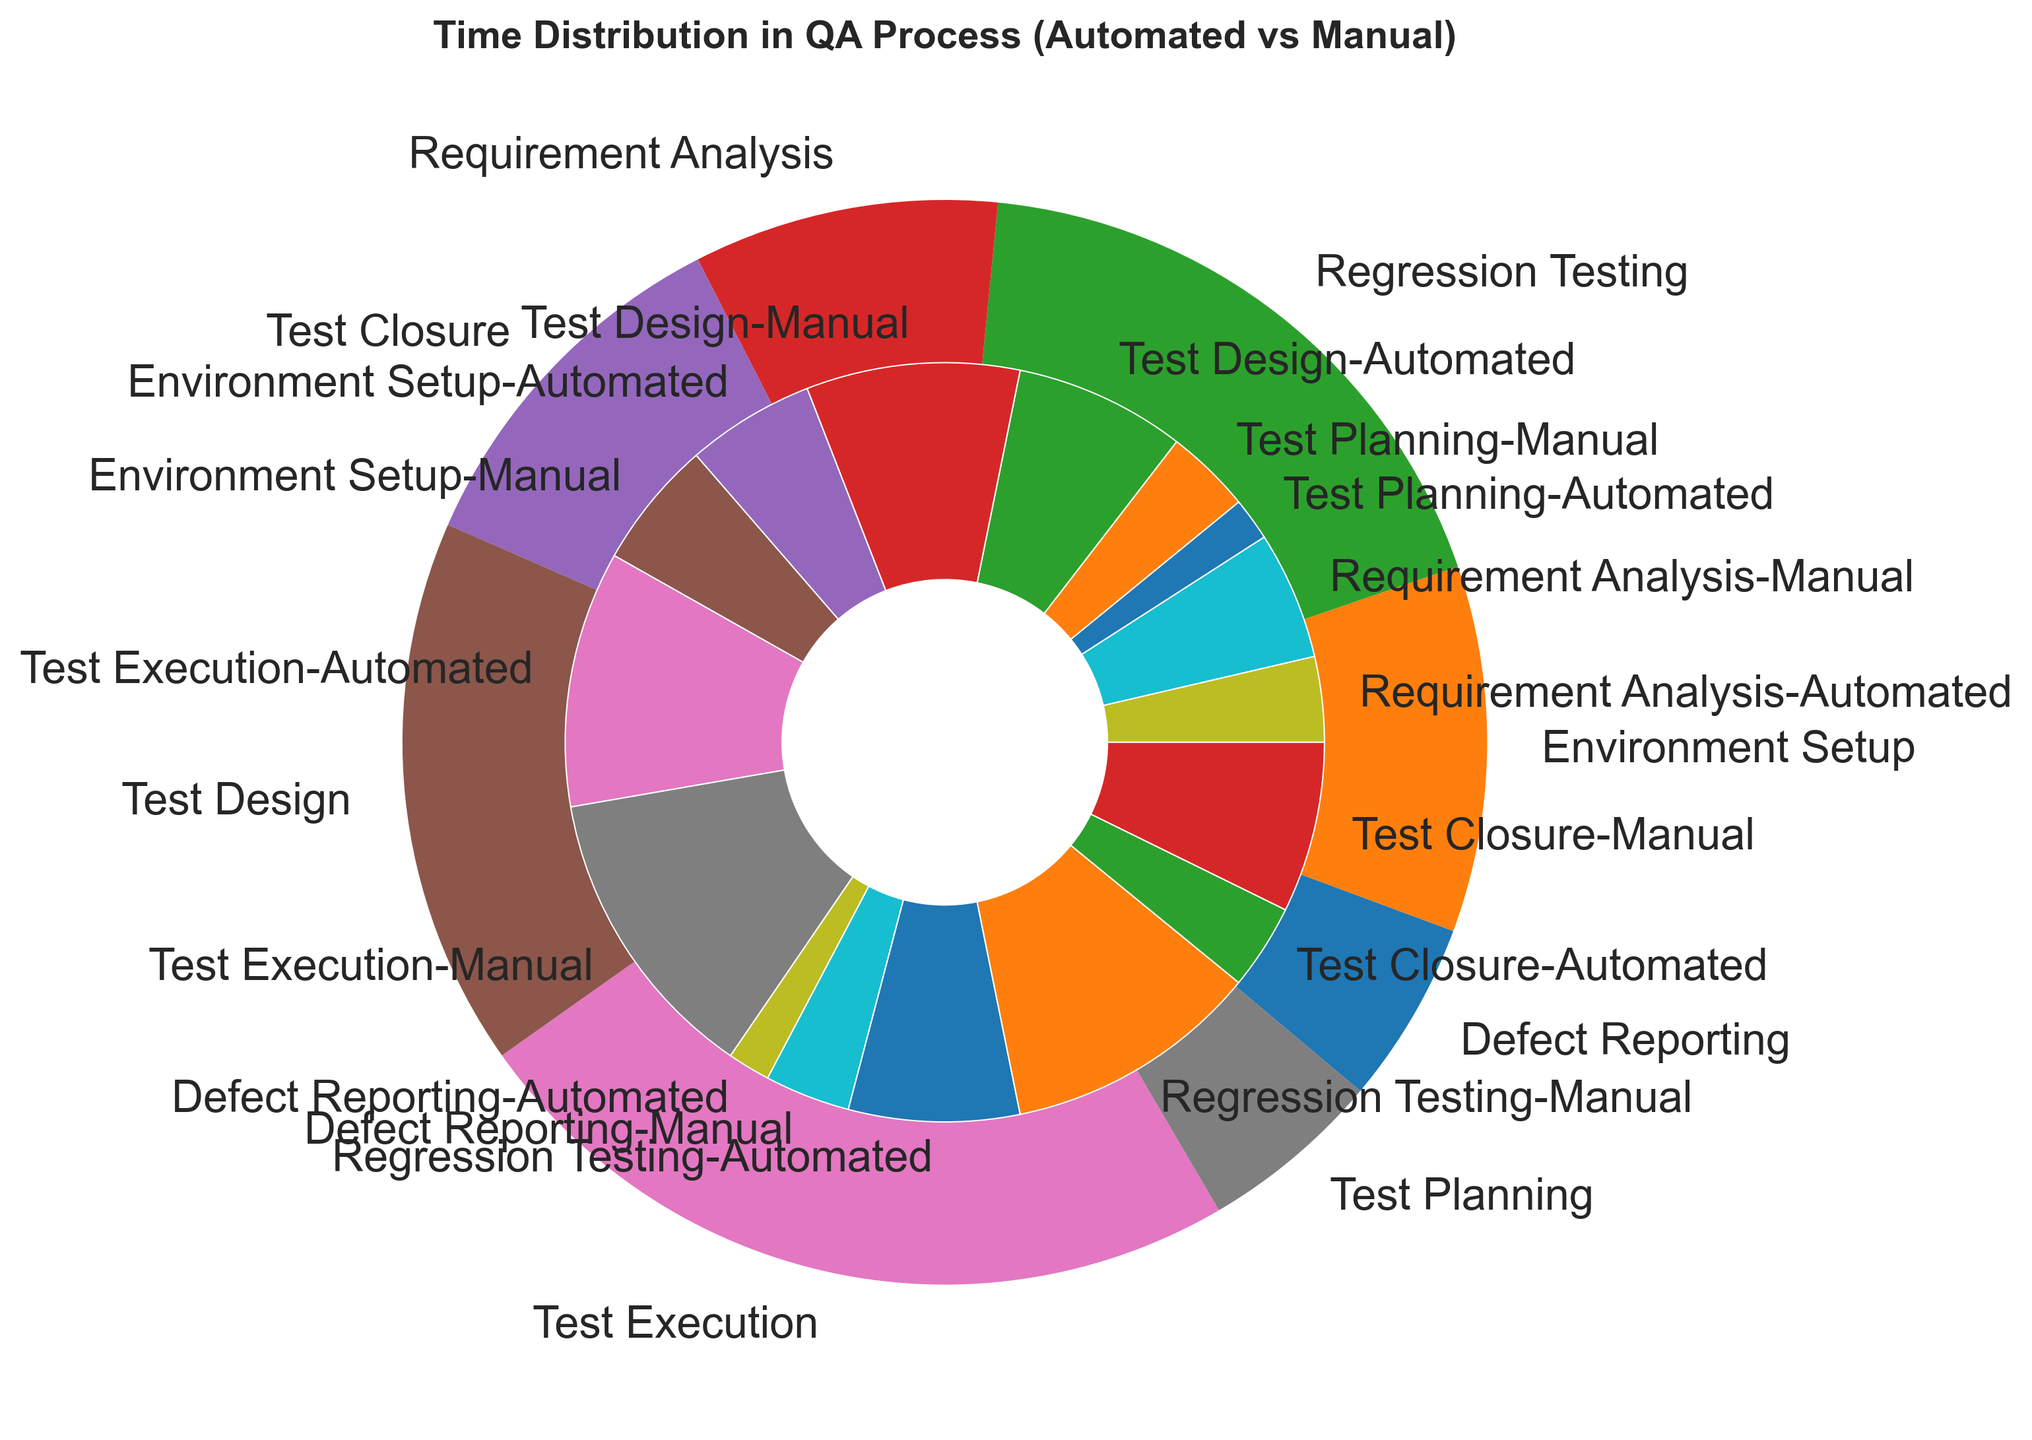What is the total time spent on Requirement Analysis? Add the time spent on both Automated (2 hours) and Manual (3 hours) stages for Requirement Analysis. 2 + 3 = 5
Answer: 5 hours Which stage takes the longest total time in the QA process? Identify the stage with the largest wedge in the outer pie chart. Test Execution has the largest segment.
Answer: Test Execution Which type of testing (Automated or Manual) takes more time overall in the QA process? Look at the sum of hours for both Automated and Manual testing stages across all segments. Manual testing stages have a larger overall cumulative sum.
Answer: Manual Between Test Planning and Test Closure stages, which one takes more time for Manual testing? Compare the sizes of the manual wedges for Test Planning (2 hours) and Test Closure (4 hours). Test Closure has a larger size.
Answer: Test Closure What is the difference in time spent on Automated vs. Manual testing for the Test Design stage? Subtract the time for Automated testing (4 hours) from Manual testing (5 hours) for the Test Design stage. 5 - 4 = 1
Answer: 1 hour How does the time spent on Environment Setup compare between Automated and Manual testing? Look at the inner pie chart to compare the sections of Environment Setup for Automated (3 hours) and Manual (3 hours). Both are equal in size.
Answer: Equal For Defect Reporting, what fraction of the total time is spent on Automated testing? Calculate the fraction of time spent on Automated Defect Reporting (1 hour) out of the total (1 + 2 = 3 hours). 1/3
Answer: 1/3 Which stage has equal time allocated for both Automated and Manual steps? Find the segment in the inner pie chart where Automated and Manual wedges are of equal size. Environment Setup (3 hours each).
Answer: Environment Setup If you sum up the time spent on Automated testing for Test Execution and Regression Testing, what do you get? Add the times for Automated Test Execution (6 hours) and Regression Testing (4 hours). 6 + 4 = 10
Answer: 10 hours What is the proportion of time spent on Test Planning (Manual) compared to the total QA process time? Calculate the proportion: (2 hours for Manual Test Planning) divided by the total process time (all stages' hours summed). (2 / 55)
Answer: 2/55 